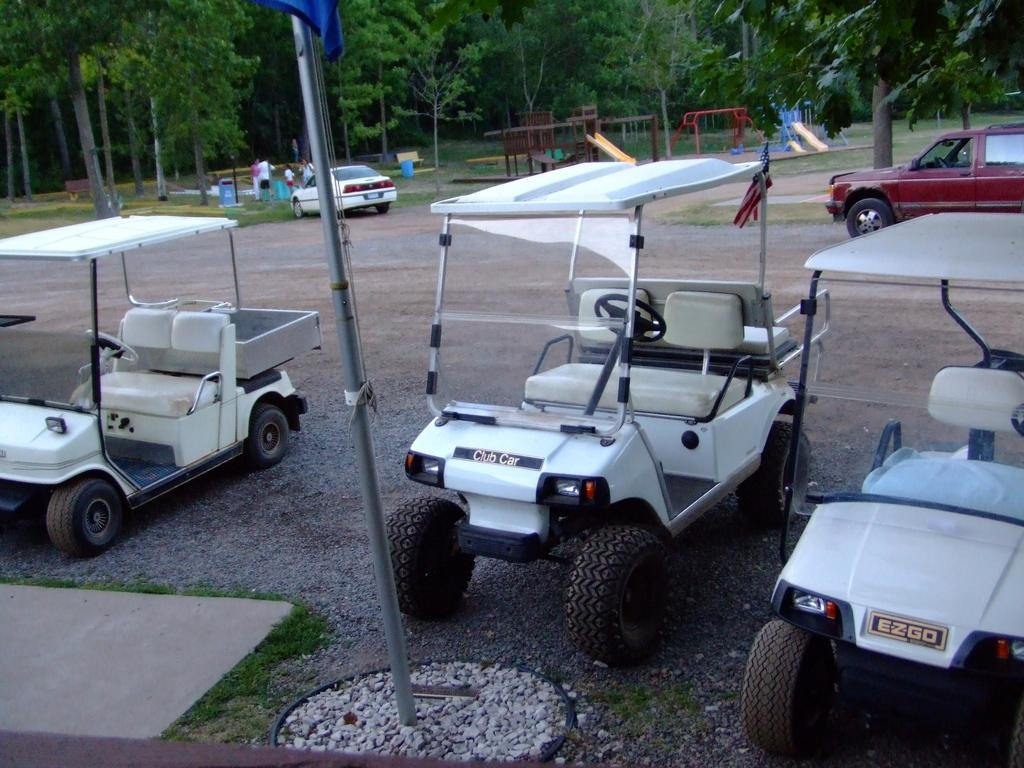What type of vehicles can be seen in the image? There are cars in the image. What type of surface are the carts and cars on? Flagstones are present in the image. Who or what is visible in the image besides the carts, cars, and flagstones? There is a group of people in the image. What type of natural environment is visible in the image? Grass is visible in the image. What can be seen in the background of the image? There are trees in the background of the image. What type of ticket does the queen hold in the image? There is no queen or ticket present in the image. Is there a notebook visible in the image? There is no notebook present in the image. 